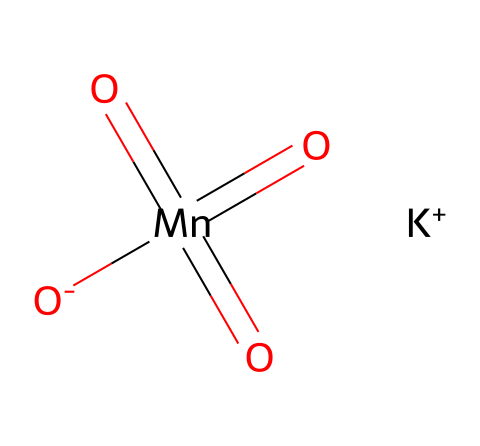What is the formula for potassium permanganate? The SMILES representation indicates the presence of potassium (K), manganese (Mn), and oxygen (O) in the structure, which corresponds to the chemical formula KMnO4.
Answer: KMnO4 How many oxygen atoms are present in potassium permanganate? In the SMILES notation, the oxygen atoms are highlighted by the presence of the "O" symbols. The structure has four oxygen atoms connected to manganese, which can be counted from the representation.
Answer: 4 What is the oxidation state of manganese in potassium permanganate? To determine the oxidation state, we note that potassium (K) has a +1 charge, and each oxygen (O) typically has a -2 charge. The total charge balance leads to manganese having a +7 oxidation state in this compound.
Answer: +7 Is potassium permanganate an oxidizing agent? Potassium permanganate is known to act as a powerful oxidizing agent due to the high oxidation state of manganese (+7) in the chemical structure, indicating it can gain electrons readily.
Answer: Yes What type of chemical is potassium permanganate classified as? Potassium permanganate is classified as an oxidizer because of its strong oxidative properties, which are evident from its structure featuring manganese in a high oxidation state.
Answer: oxidizer How many total atoms are in potassium permanganate? In the formula KMnO4, the total number of atoms can be calculated as 1 potassium (K) + 1 manganese (Mn) + 4 oxygen (O), resulting in a total of 6 atoms.
Answer: 6 What role does potassium play in potassium permanganate? Potassium serves as a counterion balancing the negative charges from the permanganate ion (MnO4) in the structure; therefore, it stabilizes the compound in solution.
Answer: counterion 